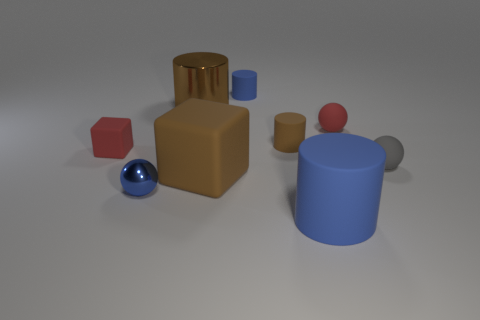Add 1 red metal blocks. How many objects exist? 10 Subtract all spheres. How many objects are left? 6 Add 8 cyan matte blocks. How many cyan matte blocks exist? 8 Subtract 0 purple cylinders. How many objects are left? 9 Subtract all red spheres. Subtract all brown shiny things. How many objects are left? 7 Add 7 tiny gray rubber balls. How many tiny gray rubber balls are left? 8 